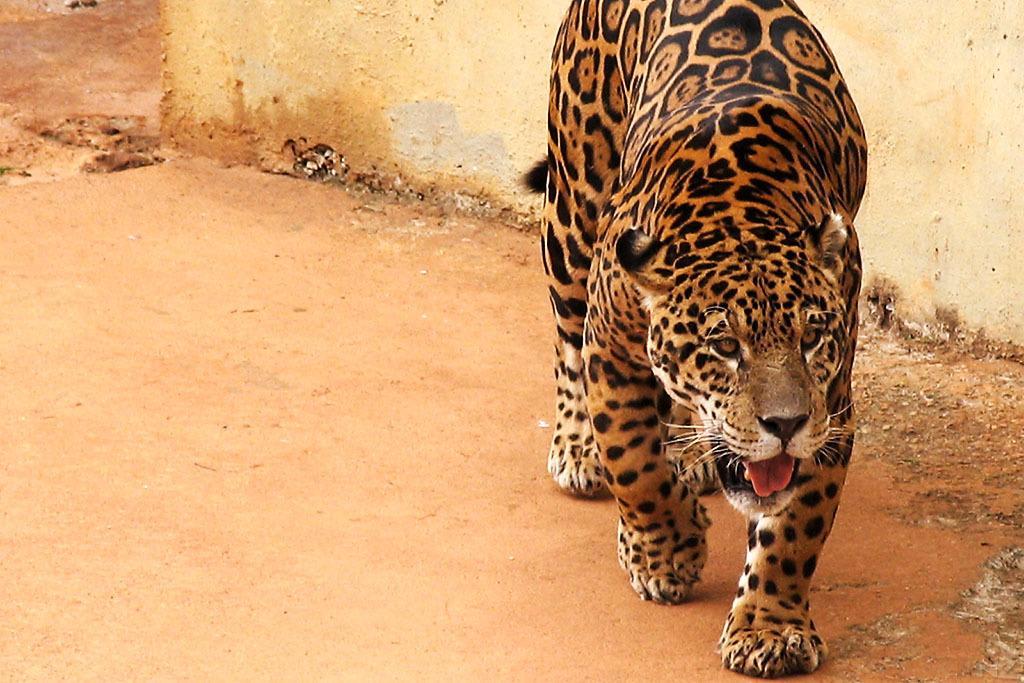Can you describe this image briefly? In this image there is a tiger and at the background there is a wall. 